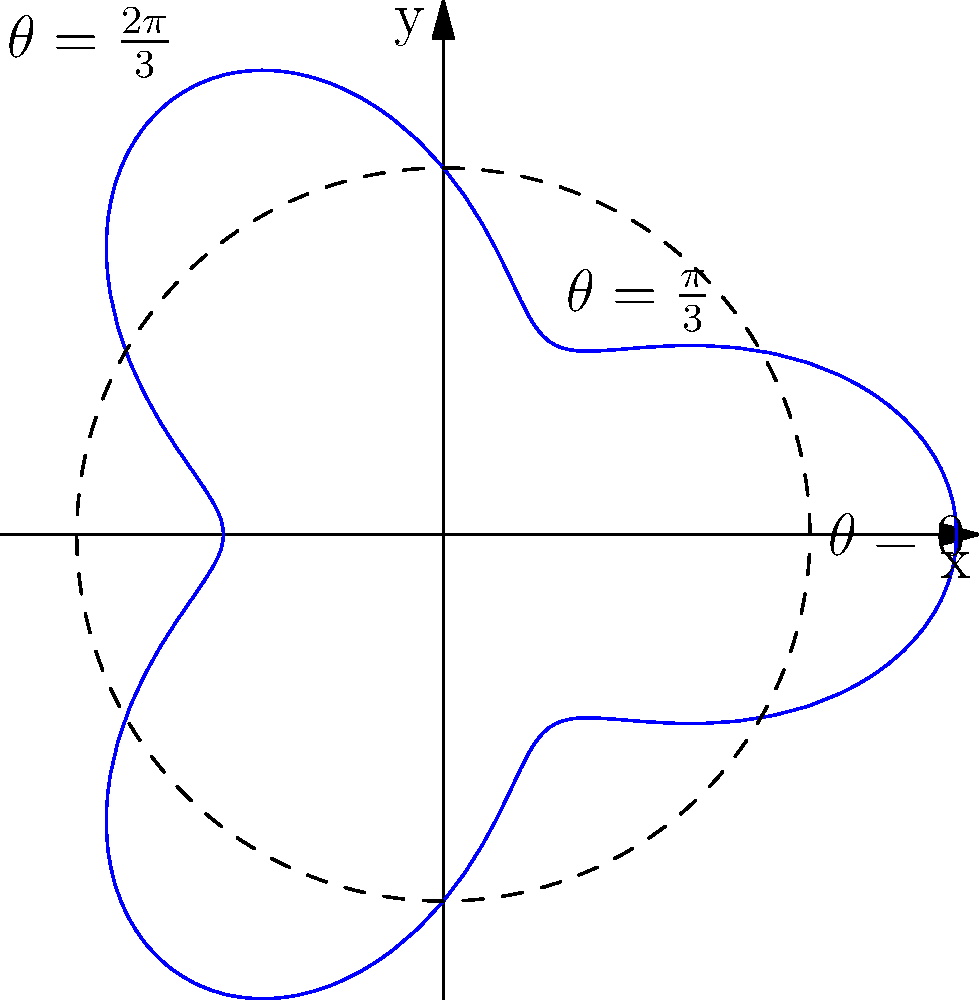En el diseño de una articulación protésica, se utiliza un mecanismo representado por la ecuación polar $r = 5 + 2\cos(3\theta)$ (en cm). Si la articulación rota desde $\theta = 0$ hasta $\theta = \frac{2\pi}{3}$, ¿cuál es el desplazamiento radial total experimentado por el punto de referencia en la articulación? Para resolver este problema, seguiremos estos pasos:

1) La ecuación polar dada es $r = 5 + 2\cos(3\theta)$.

2) Necesitamos calcular $r$ en $\theta = 0$ y $\theta = \frac{2\pi}{3}$:

   Para $\theta = 0$:
   $r_0 = 5 + 2\cos(3 \cdot 0) = 5 + 2 \cdot 1 = 7$ cm

   Para $\theta = \frac{2\pi}{3}$:
   $r_{2\pi/3} = 5 + 2\cos(3 \cdot \frac{2\pi}{3}) = 5 + 2\cos(2\pi) = 5 + 2 \cdot 1 = 7$ cm

3) El desplazamiento radial es la diferencia entre estos dos valores:

   $\Delta r = |r_{2\pi/3} - r_0| = |7 - 7| = 0$ cm

4) Esto significa que aunque la articulación ha rotado, el punto de referencia ha vuelto a su posición radial original.

Es importante notar que aunque el desplazamiento neto es cero, el punto ha pasado por diferentes posiciones radiales durante la rotación, como se puede ver en la gráfica.
Answer: 0 cm 